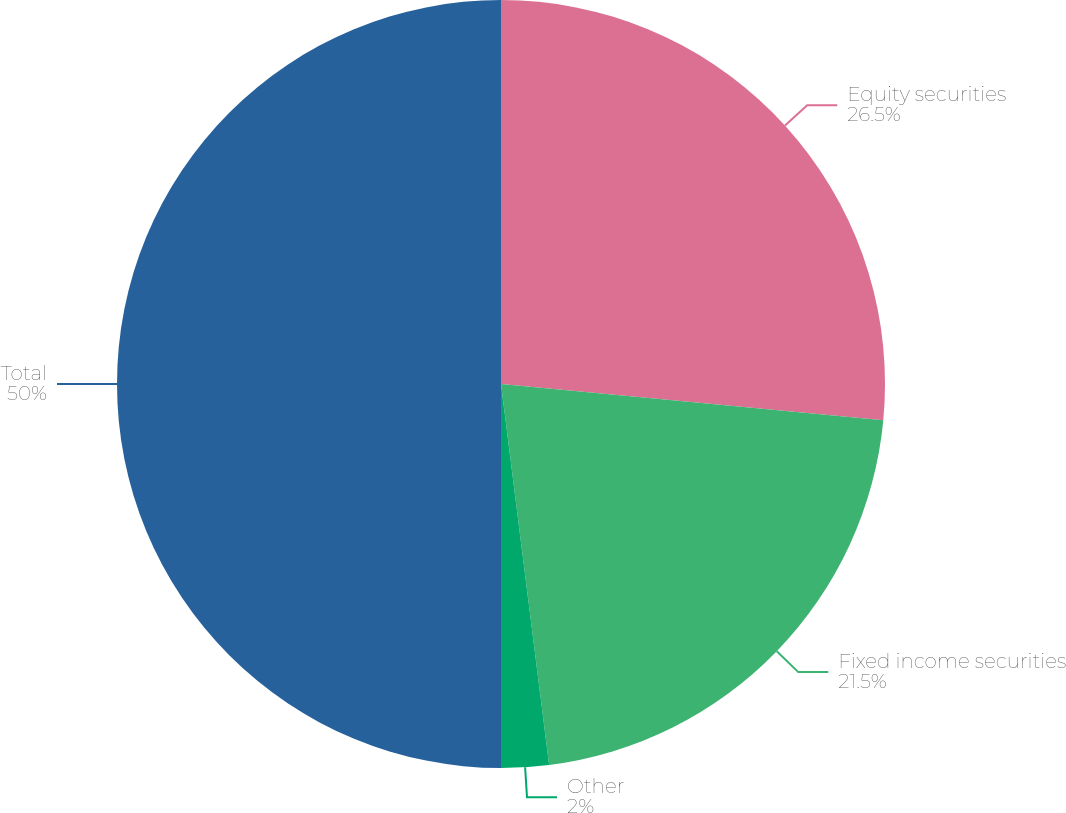Convert chart. <chart><loc_0><loc_0><loc_500><loc_500><pie_chart><fcel>Equity securities<fcel>Fixed income securities<fcel>Other<fcel>Total<nl><fcel>26.5%<fcel>21.5%<fcel>2.0%<fcel>50.0%<nl></chart> 